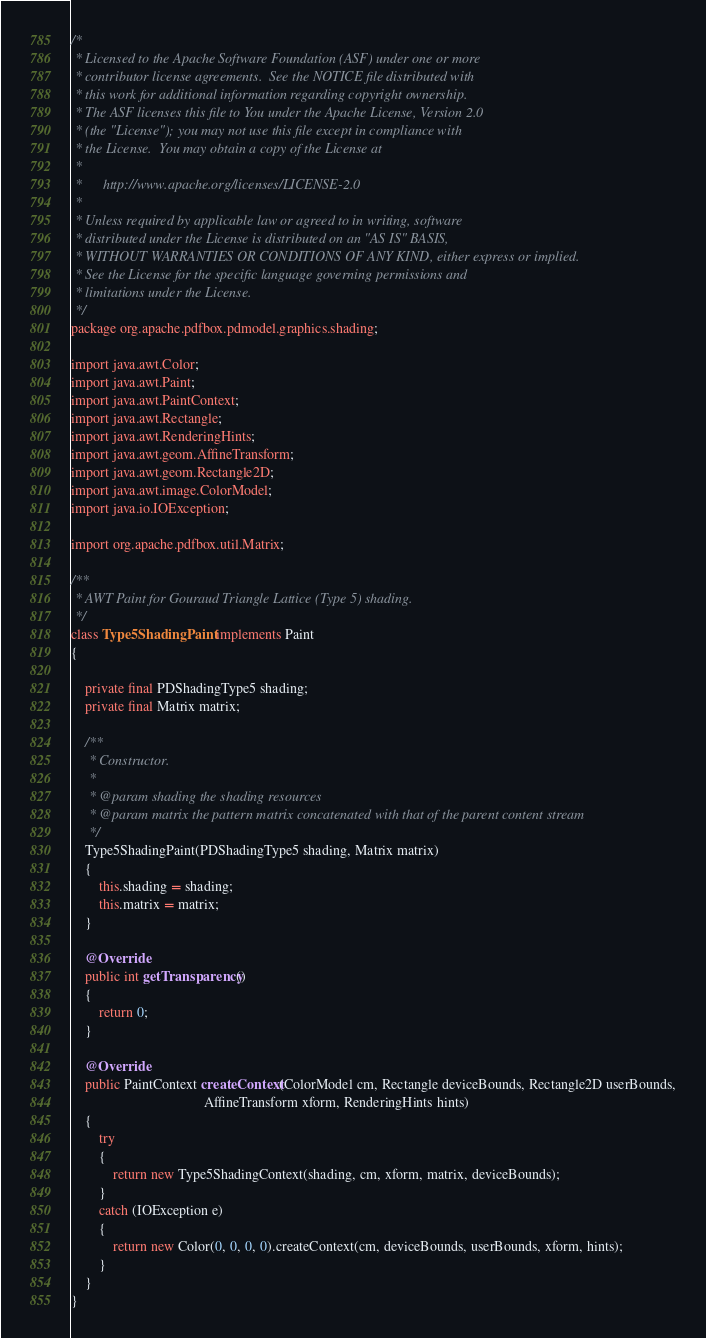Convert code to text. <code><loc_0><loc_0><loc_500><loc_500><_Java_>/*
 * Licensed to the Apache Software Foundation (ASF) under one or more
 * contributor license agreements.  See the NOTICE file distributed with
 * this work for additional information regarding copyright ownership.
 * The ASF licenses this file to You under the Apache License, Version 2.0
 * (the "License"); you may not use this file except in compliance with
 * the License.  You may obtain a copy of the License at
 *
 *      http://www.apache.org/licenses/LICENSE-2.0
 *
 * Unless required by applicable law or agreed to in writing, software
 * distributed under the License is distributed on an "AS IS" BASIS,
 * WITHOUT WARRANTIES OR CONDITIONS OF ANY KIND, either express or implied.
 * See the License for the specific language governing permissions and
 * limitations under the License.
 */
package org.apache.pdfbox.pdmodel.graphics.shading;

import java.awt.Color;
import java.awt.Paint;
import java.awt.PaintContext;
import java.awt.Rectangle;
import java.awt.RenderingHints;
import java.awt.geom.AffineTransform;
import java.awt.geom.Rectangle2D;
import java.awt.image.ColorModel;
import java.io.IOException;

import org.apache.pdfbox.util.Matrix;

/**
 * AWT Paint for Gouraud Triangle Lattice (Type 5) shading.
 */
class Type5ShadingPaint implements Paint
{

    private final PDShadingType5 shading;
    private final Matrix matrix;

    /**
     * Constructor.
     *
     * @param shading the shading resources
     * @param matrix the pattern matrix concatenated with that of the parent content stream
     */
    Type5ShadingPaint(PDShadingType5 shading, Matrix matrix)
    {
        this.shading = shading;
        this.matrix = matrix;
    }

    @Override
    public int getTransparency()
    {
        return 0;
    }

    @Override
    public PaintContext createContext(ColorModel cm, Rectangle deviceBounds, Rectangle2D userBounds,
                                      AffineTransform xform, RenderingHints hints)
    {
        try
        {
            return new Type5ShadingContext(shading, cm, xform, matrix, deviceBounds);
        }
        catch (IOException e)
        {
            return new Color(0, 0, 0, 0).createContext(cm, deviceBounds, userBounds, xform, hints);
        }
    }
}
</code> 